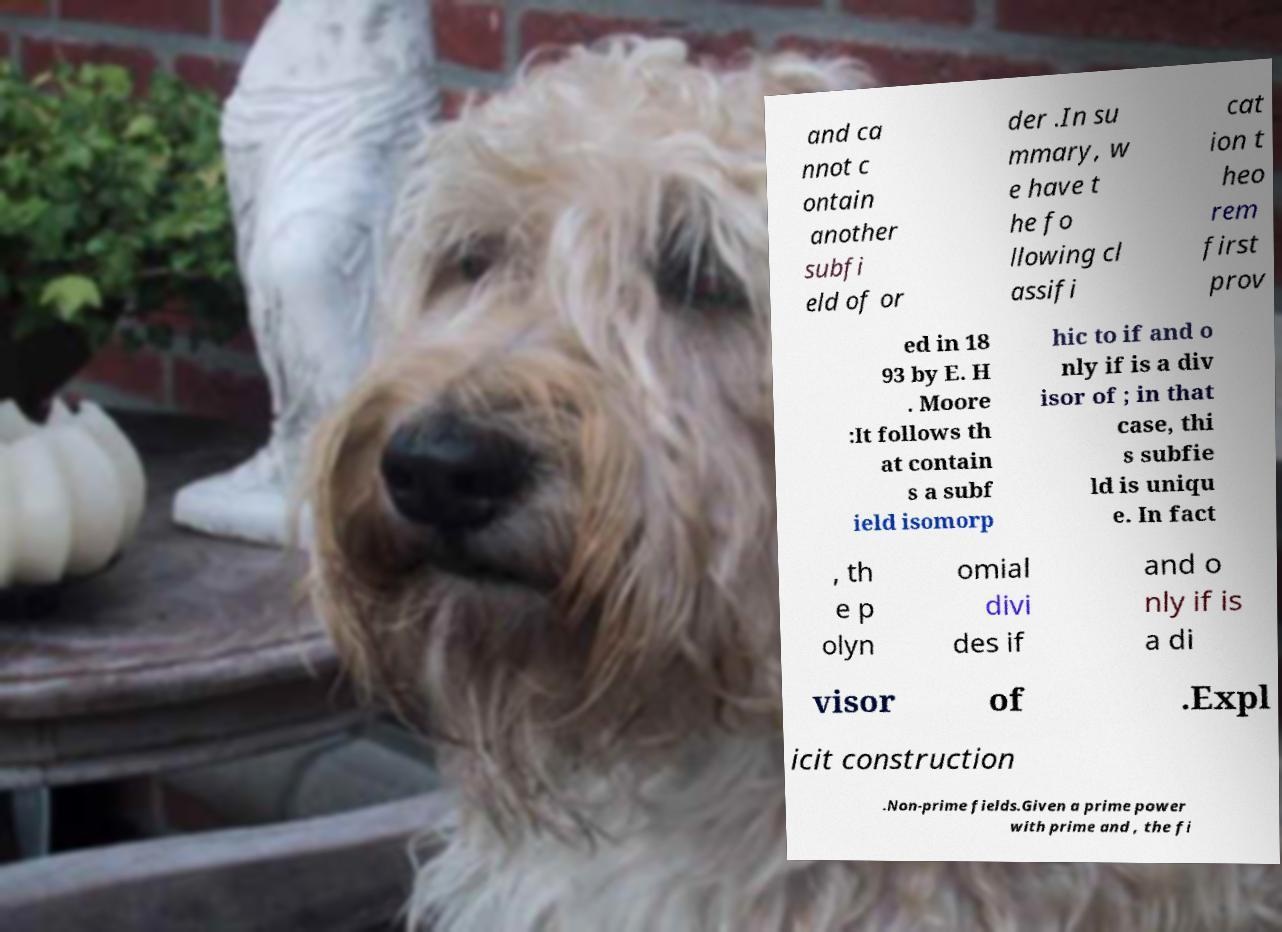Could you extract and type out the text from this image? and ca nnot c ontain another subfi eld of or der .In su mmary, w e have t he fo llowing cl assifi cat ion t heo rem first prov ed in 18 93 by E. H . Moore :It follows th at contain s a subf ield isomorp hic to if and o nly if is a div isor of ; in that case, thi s subfie ld is uniqu e. In fact , th e p olyn omial divi des if and o nly if is a di visor of .Expl icit construction .Non-prime fields.Given a prime power with prime and , the fi 